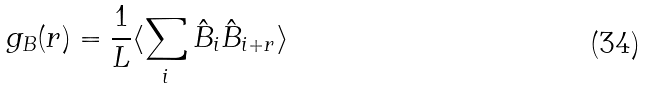<formula> <loc_0><loc_0><loc_500><loc_500>g _ { B } ( r ) = \frac { 1 } { L } \langle \sum _ { i } \hat { B } _ { i } \hat { B } _ { i + r } \rangle</formula> 